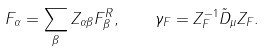Convert formula to latex. <formula><loc_0><loc_0><loc_500><loc_500>F _ { \alpha } = \sum _ { \beta } Z _ { \alpha \beta } F _ { \beta } ^ { R } , \quad \gamma _ { F } = Z _ { F } ^ { - 1 } \tilde { D } _ { \mu } Z _ { F } .</formula> 